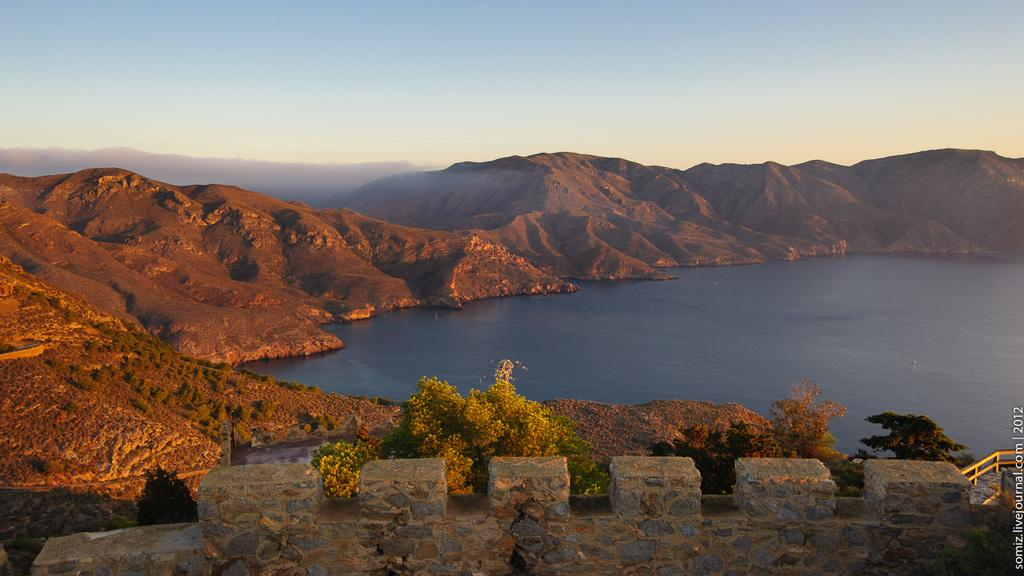What is located at the bottom of the image? There is a wall at the bottom of the image. What is in front of the wall? There is a railing in front of the wall. What is in front of the railing? There are trees in front of the railing. What natural feature can be seen in the image? There is a river visible in the image. What type of landscape is visible in the image? There are mountains in the image. What is visible in the top part of the image? The sky is visible in the image. What is the chance of winning the lottery in the image? There is no information about the lottery or winning chances in the image. How does the number of trees compare to the number of mountains in the image? The image does not provide information about the number of trees or mountains, so it is impossible to make a comparison. 